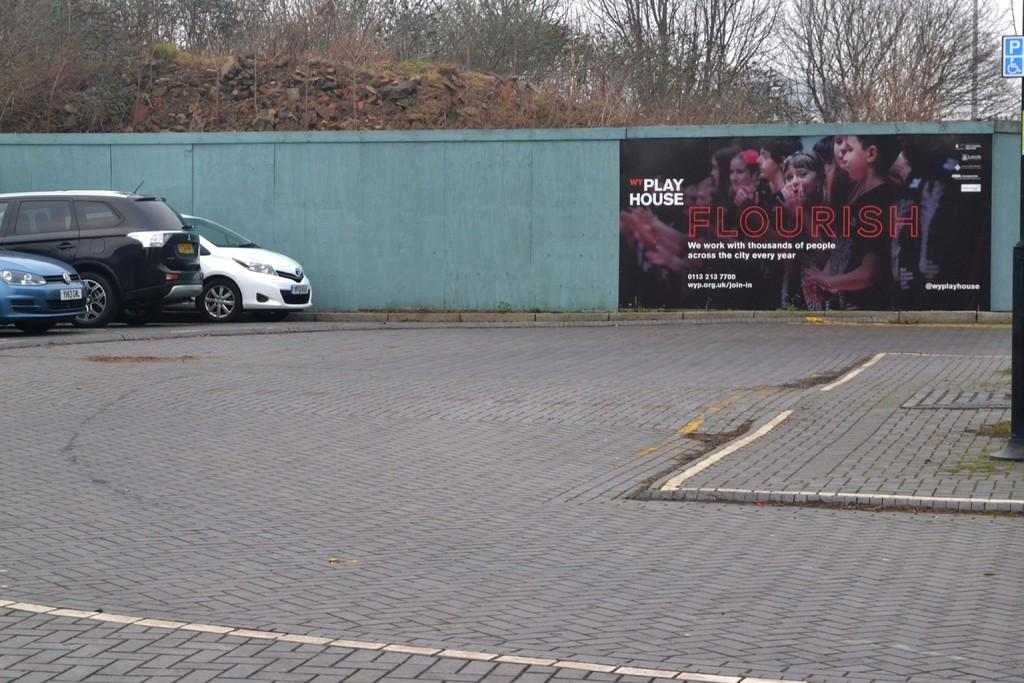What can be seen on the road in the image? There are cars on the road in the image. What is located near the road in the image? There is a wall in the image. What is hanging on the wall in the image? There is a poster in the image. What is the board used for in the image? The board's purpose is not clear from the image, but it is present. What type of vegetation is visible in the background of the image? There are trees in the background of the image. What is visible in the sky in the background of the image? The sky is visible in the background of the image. Can you tell me how many ducks are swimming in the water in the image? There is no water or ducks present in the image; it features cars on the road, a wall, a poster, a board, trees, and the sky. 